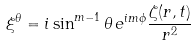Convert formula to latex. <formula><loc_0><loc_0><loc_500><loc_500>\xi ^ { \theta } = i \sin ^ { m - 1 } \theta \, e ^ { i m \phi } \frac { \zeta ( r , t ) } { r ^ { 2 } }</formula> 